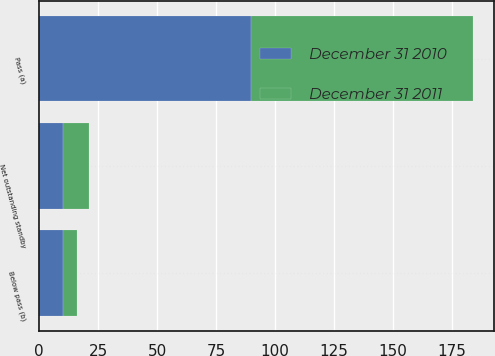Convert chart. <chart><loc_0><loc_0><loc_500><loc_500><stacked_bar_chart><ecel><fcel>Net outstanding standby<fcel>Pass (a)<fcel>Below pass (b)<nl><fcel>December 31 2011<fcel>10.8<fcel>94<fcel>6<nl><fcel>December 31 2010<fcel>10.1<fcel>90<fcel>10<nl></chart> 